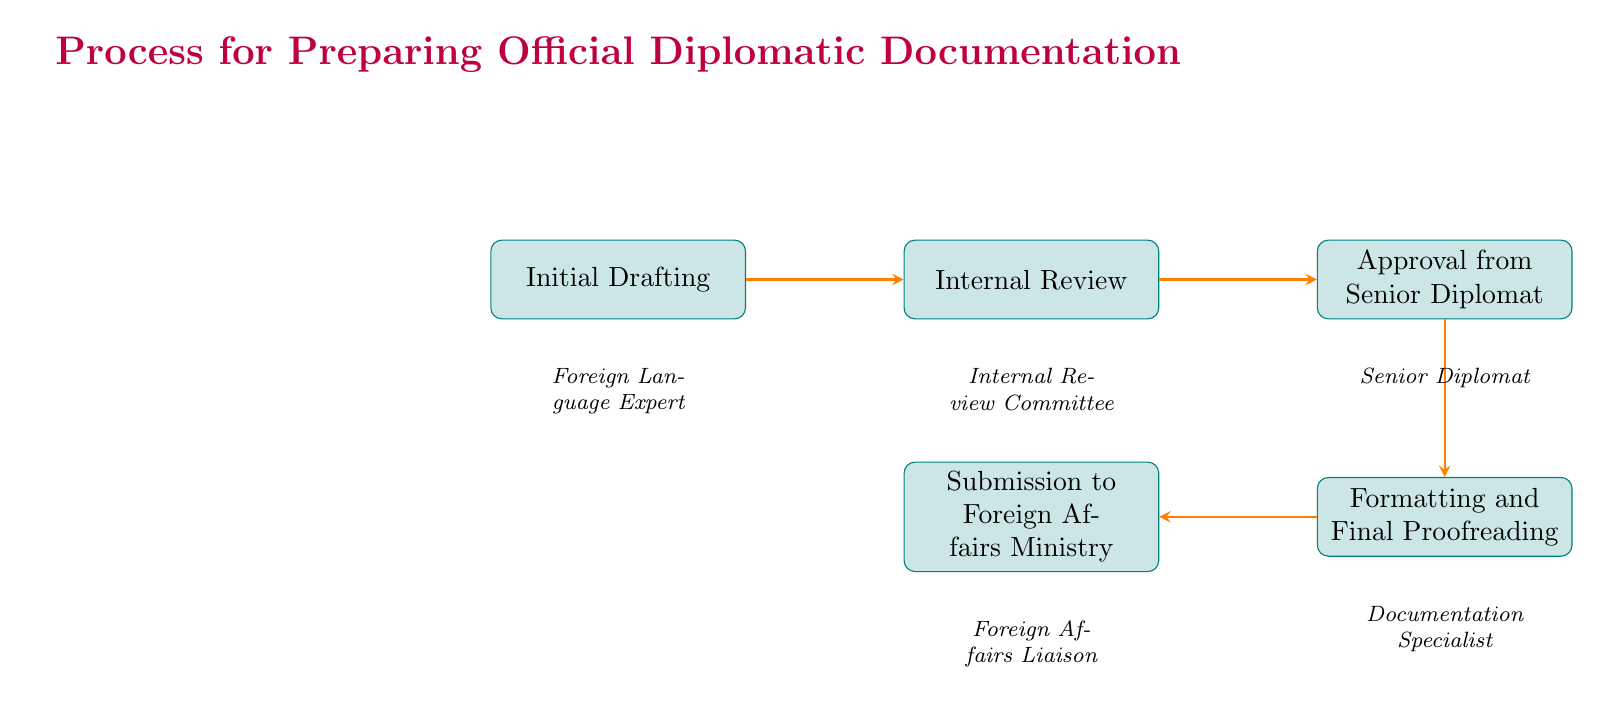What is the first step in the process? The diagram shows the first node labeled "Initial Drafting," indicating that this is the initial step in the process of preparing diplomatic documentation.
Answer: Initial Drafting Which entity is responsible for the "Approval from Senior Diplomat" step? Each node in the diagram notes the responsible entity below it, and in the case of "Approval from Senior Diplomat," it specifies "Senior Diplomat" as the entity responsible for this step.
Answer: Senior Diplomat How many steps are there in the process? By counting the nodes present in the diagram, there are five distinct steps mentioned: Initial Drafting, Internal Review, Approval from Senior Diplomat, Formatting and Final Proofreading, and Submission to Foreign Affairs Ministry.
Answer: Five What follows "Internal Review" in the flow? Referring to the arrows connecting the nodes, "Approval from Senior Diplomat" is the immediate next step that follows "Internal Review" in the process flow.
Answer: Approval from Senior Diplomat What type of document is being prepared in this process? The title of the diagram itself indicates that this is a process specifically for preparing "Official Diplomatic Documentation," identifying the nature of the documents involved.
Answer: Official Diplomatic Documentation Which step involves proofreading for errors? The step that is dedicated to proofreading for errors is "Formatting and Final Proofreading," as indicated by its associated key action listed under this step.
Answer: Formatting and Final Proofreading What is the last step in the process? The last node in the flow chart indicates that the final step before the conclusion of the process is "Submission to Foreign Affairs Ministry."
Answer: Submission to Foreign Affairs Ministry Which entity handles the final submission of the document? By examining the responsible entities associated with each node, "Foreign Affairs Liaison" is indicated as the entity in charge of the final submission step.
Answer: Foreign Affairs Liaison What key actions are performed in "Internal Review"? The steps mentioned in the key actions for "Internal Review" include "Cultural sensitivity check," "Diplomatic language review," and "Amendments," all of which fulfill the review process.
Answer: Cultural sensitivity check, Diplomatic language review, Amendments 